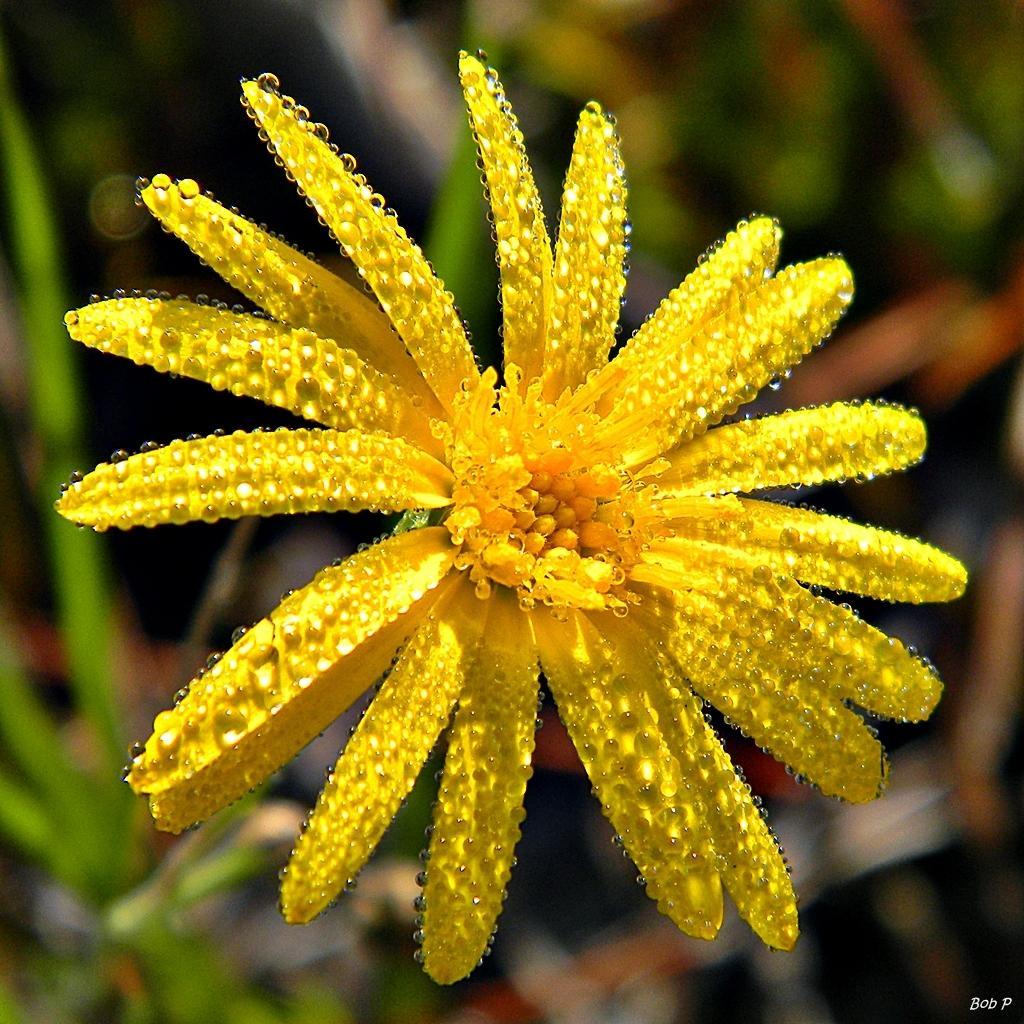Could you give a brief overview of what you see in this image? In this picture we can see a flower and in the background we can see it is blurry, in the bottom right we can see some text on it. 